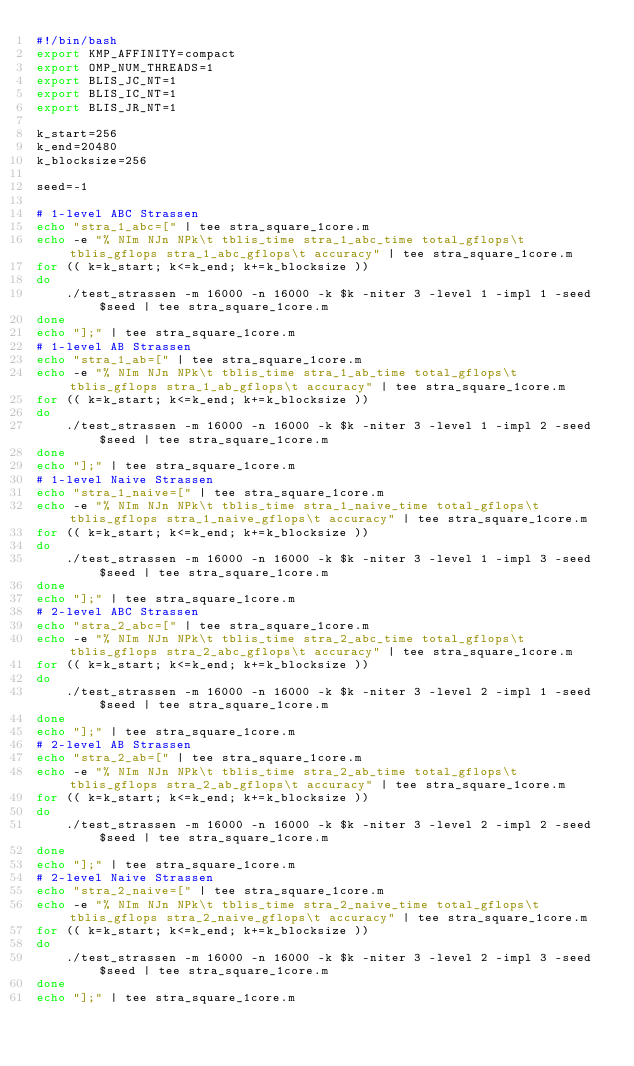Convert code to text. <code><loc_0><loc_0><loc_500><loc_500><_Bash_>#!/bin/bash
export KMP_AFFINITY=compact
export OMP_NUM_THREADS=1
export BLIS_JC_NT=1
export BLIS_IC_NT=1
export BLIS_JR_NT=1

k_start=256
k_end=20480
k_blocksize=256

seed=-1

# 1-level ABC Strassen
echo "stra_1_abc=[" | tee stra_square_1core.m
echo -e "% NIm NJn NPk\t tblis_time stra_1_abc_time total_gflops\t tblis_gflops stra_1_abc_gflops\t accuracy" | tee stra_square_1core.m
for (( k=k_start; k<=k_end; k+=k_blocksize ))
do
    ./test_strassen -m 16000 -n 16000 -k $k -niter 3 -level 1 -impl 1 -seed $seed | tee stra_square_1core.m
done
echo "];" | tee stra_square_1core.m
# 1-level AB Strassen
echo "stra_1_ab=[" | tee stra_square_1core.m
echo -e "% NIm NJn NPk\t tblis_time stra_1_ab_time total_gflops\t tblis_gflops stra_1_ab_gflops\t accuracy" | tee stra_square_1core.m
for (( k=k_start; k<=k_end; k+=k_blocksize ))
do
    ./test_strassen -m 16000 -n 16000 -k $k -niter 3 -level 1 -impl 2 -seed $seed | tee stra_square_1core.m
done
echo "];" | tee stra_square_1core.m
# 1-level Naive Strassen
echo "stra_1_naive=[" | tee stra_square_1core.m
echo -e "% NIm NJn NPk\t tblis_time stra_1_naive_time total_gflops\t tblis_gflops stra_1_naive_gflops\t accuracy" | tee stra_square_1core.m
for (( k=k_start; k<=k_end; k+=k_blocksize ))
do
    ./test_strassen -m 16000 -n 16000 -k $k -niter 3 -level 1 -impl 3 -seed $seed | tee stra_square_1core.m
done
echo "];" | tee stra_square_1core.m
# 2-level ABC Strassen
echo "stra_2_abc=[" | tee stra_square_1core.m
echo -e "% NIm NJn NPk\t tblis_time stra_2_abc_time total_gflops\t tblis_gflops stra_2_abc_gflops\t accuracy" | tee stra_square_1core.m
for (( k=k_start; k<=k_end; k+=k_blocksize ))
do
    ./test_strassen -m 16000 -n 16000 -k $k -niter 3 -level 2 -impl 1 -seed $seed | tee stra_square_1core.m
done
echo "];" | tee stra_square_1core.m
# 2-level AB Strassen
echo "stra_2_ab=[" | tee stra_square_1core.m
echo -e "% NIm NJn NPk\t tblis_time stra_2_ab_time total_gflops\t tblis_gflops stra_2_ab_gflops\t accuracy" | tee stra_square_1core.m
for (( k=k_start; k<=k_end; k+=k_blocksize ))
do
    ./test_strassen -m 16000 -n 16000 -k $k -niter 3 -level 2 -impl 2 -seed $seed | tee stra_square_1core.m
done
echo "];" | tee stra_square_1core.m
# 2-level Naive Strassen
echo "stra_2_naive=[" | tee stra_square_1core.m
echo -e "% NIm NJn NPk\t tblis_time stra_2_naive_time total_gflops\t tblis_gflops stra_2_naive_gflops\t accuracy" | tee stra_square_1core.m
for (( k=k_start; k<=k_end; k+=k_blocksize ))
do
    ./test_strassen -m 16000 -n 16000 -k $k -niter 3 -level 2 -impl 3 -seed $seed | tee stra_square_1core.m
done
echo "];" | tee stra_square_1core.m

</code> 